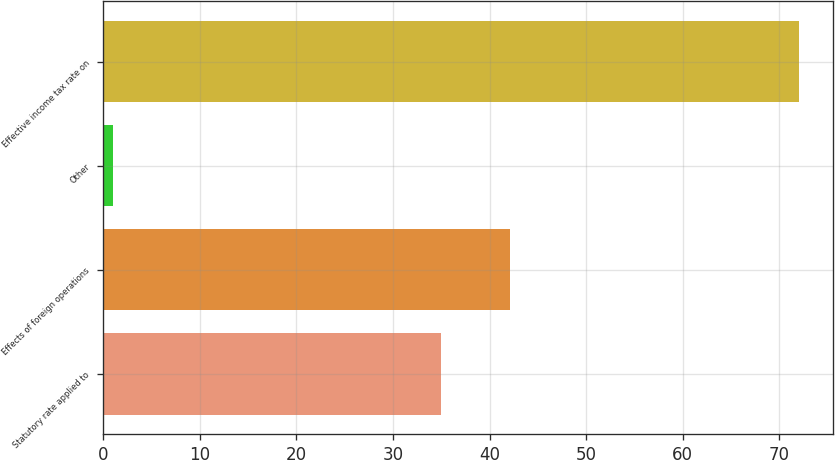Convert chart. <chart><loc_0><loc_0><loc_500><loc_500><bar_chart><fcel>Statutory rate applied to<fcel>Effects of foreign operations<fcel>Other<fcel>Effective income tax rate on<nl><fcel>35<fcel>42.1<fcel>1<fcel>72<nl></chart> 